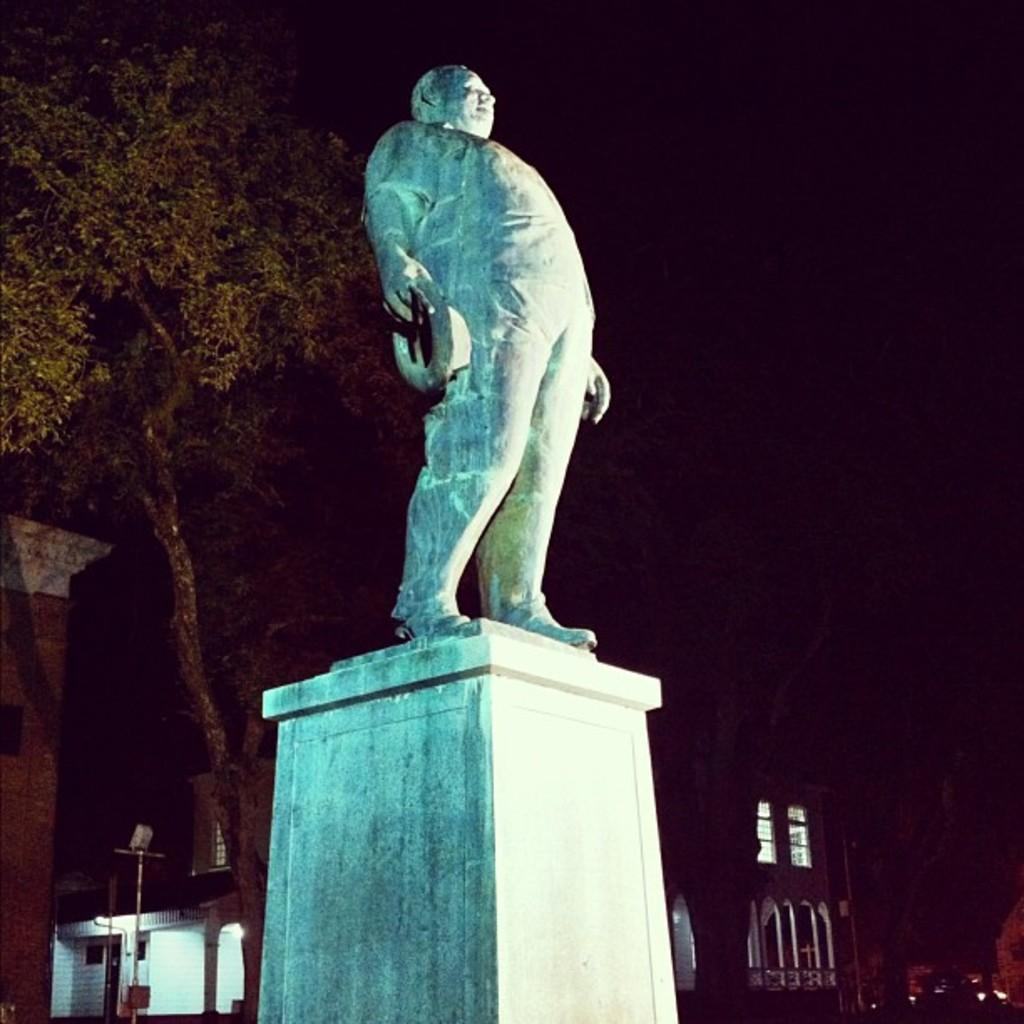What is the main subject in the image? There is a statue in the image. What other objects or features can be seen in the image? There is a tree and buildings in the image. What type of request does the daughter make in the image? There is no daughter present in the image, and therefore no such request can be observed. 